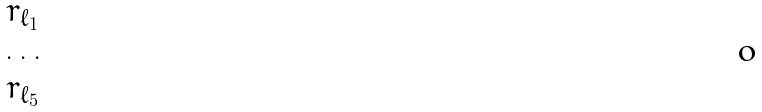Convert formula to latex. <formula><loc_0><loc_0><loc_500><loc_500>\begin{matrix} r _ { \ell _ { 1 } } \\ \dots \\ r _ { \ell _ { 5 } } \end{matrix}</formula> 